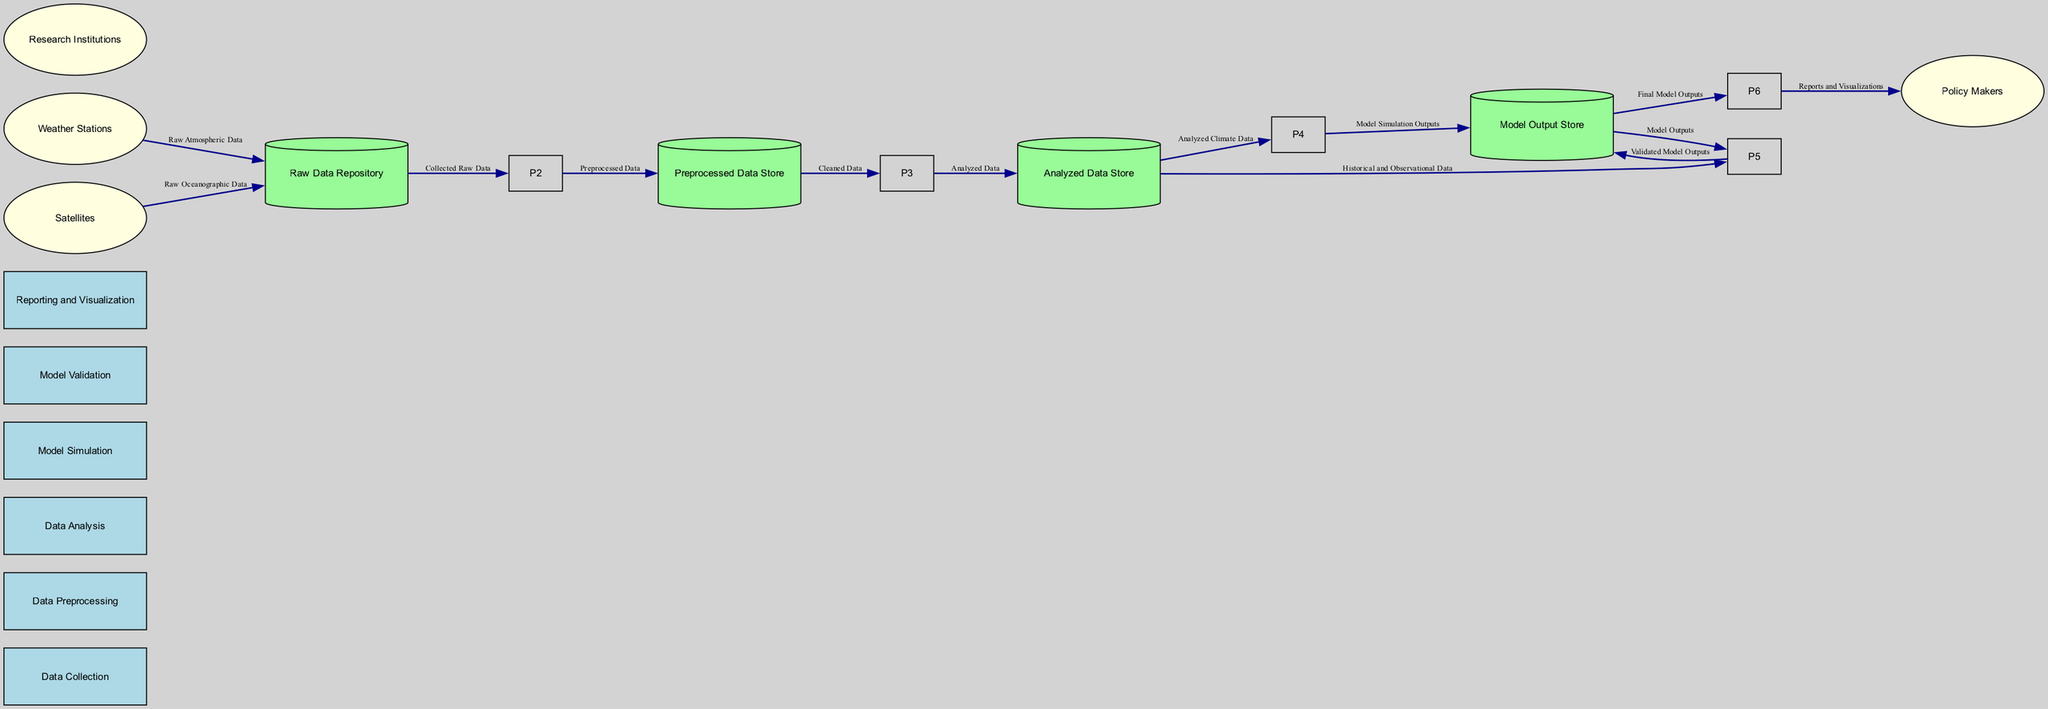What is the first process in the workflow? The diagram shows that the first process is labeled "Data Collection." This is indicated by the ordering of processes, where the first one listed is Data Collection, which collects raw atmospheric and oceanographic data.
Answer: Data Collection How many data stores are included in the diagram? Counting the data stores, we see that there are four: Raw Data Repository, Preprocessed Data Store, Analyzed Data Store, and Model Output Store. Thus, the total number of data stores is four.
Answer: 4 What type of data is provided by Weather Stations? The source labeled "Weather Stations" supplies "Raw Atmospheric Data," as indicated in the data flows between entities and data stores. This direct flow identifies the data type clearly.
Answer: Raw Atmospheric Data Which process receives the analyzed data? The process "Model Simulation" receives the analyzed data, specifically the data labeled "Analyzed Climate Data." This establishes a direct flow from the Analyzed Data Store to the Model Simulation process.
Answer: Model Simulation What type of external entity collaborates by providing validated observational data? The entity labeled "Research Institutions" is responsible for providing validated observational data, as depicted in the external entities section of the diagram.
Answer: Research Institutions After validation, where do the model outputs go? The validated model outputs are directed from the Model Validation process to the Model Output Store according to the diagram. This defines the flow of outputs after validation.
Answer: Model Output Store How many processes are validated against historical and observational data? Two processes utilize historical and observational data: "Model Validation" utilizes it to compare model outputs, and "Data Analysis" involves it to understand climate patterns, leading to an understanding of validation processes in the workflow.
Answer: 2 What do Policy Makers utilize from the reporting process? Policy Makers utilize "Reports and Visualizations," as indicated by the flow from the Reporting and Visualization process to the external entity labeled "Policy Makers" in the diagram.
Answer: Reports and Visualizations What data is stored in the Preprocessed Data Store? The Preprocessed Data Store holds "Preprocessed Data," which is specifically cleaned data ready for analysis, as shown in the flow linked to the Data Preprocessing process.
Answer: Preprocessed Data 